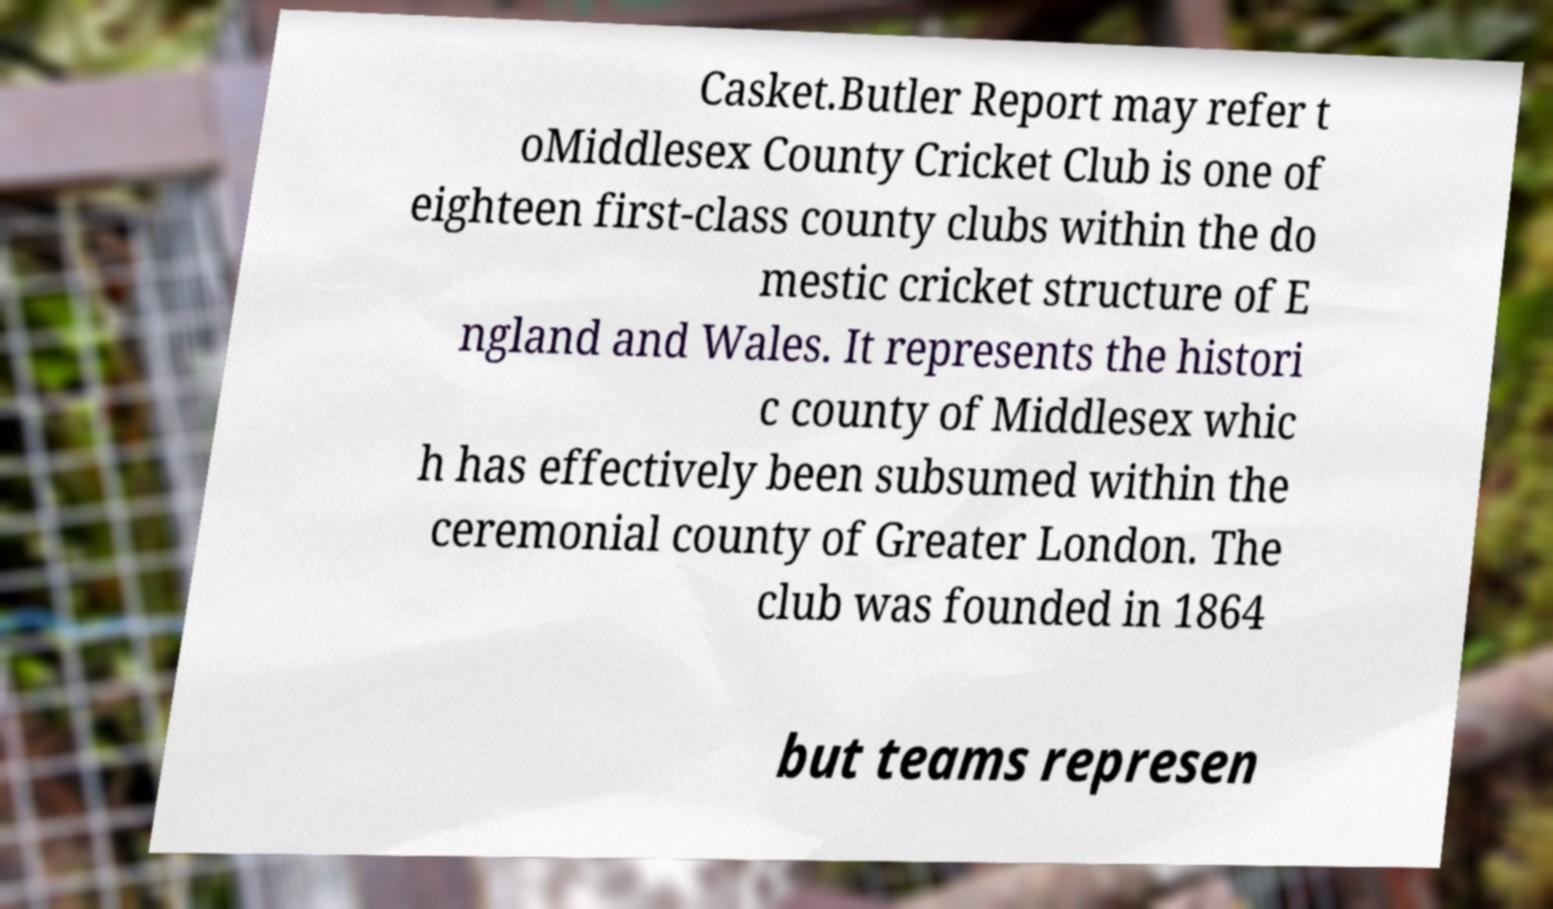Please identify and transcribe the text found in this image. Casket.Butler Report may refer t oMiddlesex County Cricket Club is one of eighteen first-class county clubs within the do mestic cricket structure of E ngland and Wales. It represents the histori c county of Middlesex whic h has effectively been subsumed within the ceremonial county of Greater London. The club was founded in 1864 but teams represen 